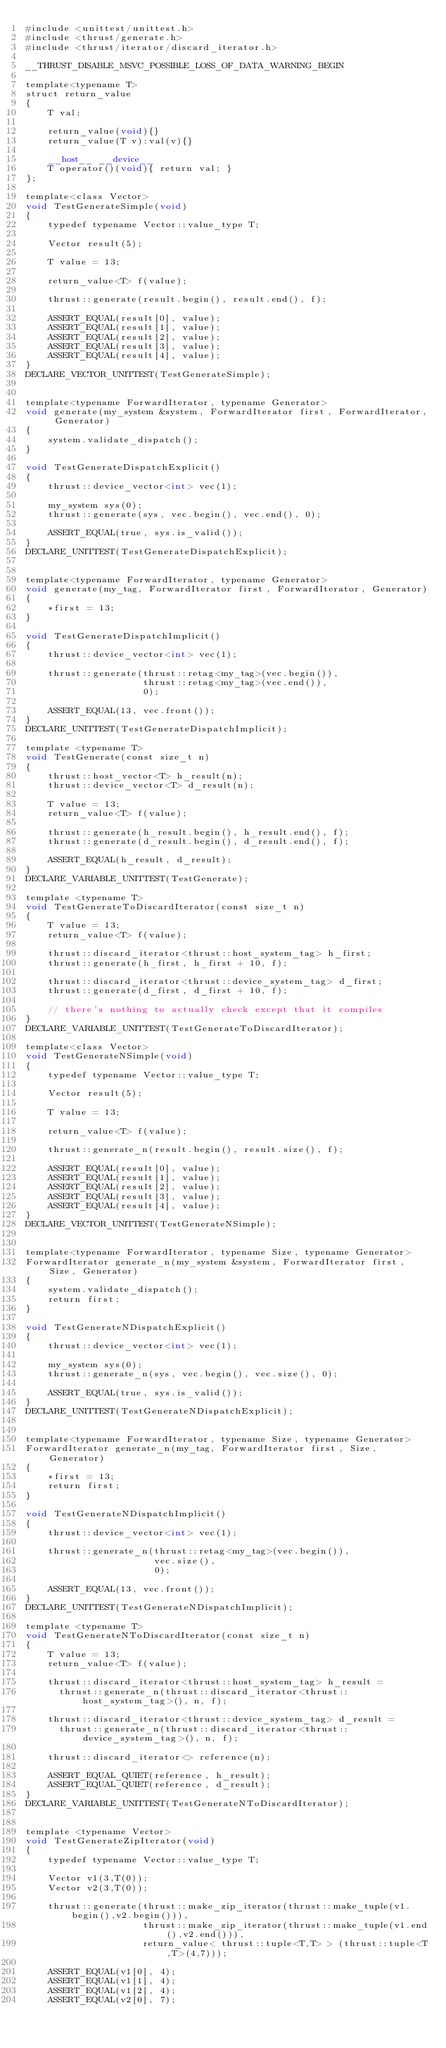Convert code to text. <code><loc_0><loc_0><loc_500><loc_500><_Cuda_>#include <unittest/unittest.h>
#include <thrust/generate.h>
#include <thrust/iterator/discard_iterator.h>

__THRUST_DISABLE_MSVC_POSSIBLE_LOSS_OF_DATA_WARNING_BEGIN

template<typename T>
struct return_value
{
    T val;

    return_value(void){}
    return_value(T v):val(v){}

    __host__ __device__
    T operator()(void){ return val; }
};

template<class Vector>
void TestGenerateSimple(void)
{
    typedef typename Vector::value_type T;

    Vector result(5);

    T value = 13;

    return_value<T> f(value);

    thrust::generate(result.begin(), result.end(), f);

    ASSERT_EQUAL(result[0], value);
    ASSERT_EQUAL(result[1], value);
    ASSERT_EQUAL(result[2], value);
    ASSERT_EQUAL(result[3], value);
    ASSERT_EQUAL(result[4], value);
}
DECLARE_VECTOR_UNITTEST(TestGenerateSimple);


template<typename ForwardIterator, typename Generator>
void generate(my_system &system, ForwardIterator first, ForwardIterator, Generator)
{
    system.validate_dispatch();
}

void TestGenerateDispatchExplicit()
{
    thrust::device_vector<int> vec(1);

    my_system sys(0);
    thrust::generate(sys, vec.begin(), vec.end(), 0);

    ASSERT_EQUAL(true, sys.is_valid());
}
DECLARE_UNITTEST(TestGenerateDispatchExplicit);


template<typename ForwardIterator, typename Generator>
void generate(my_tag, ForwardIterator first, ForwardIterator, Generator)
{
    *first = 13;
}

void TestGenerateDispatchImplicit()
{
    thrust::device_vector<int> vec(1);

    thrust::generate(thrust::retag<my_tag>(vec.begin()),
                     thrust::retag<my_tag>(vec.end()),
                     0);

    ASSERT_EQUAL(13, vec.front());
}
DECLARE_UNITTEST(TestGenerateDispatchImplicit);

template <typename T>
void TestGenerate(const size_t n)
{
    thrust::host_vector<T> h_result(n);
    thrust::device_vector<T> d_result(n);

    T value = 13;
    return_value<T> f(value);

    thrust::generate(h_result.begin(), h_result.end(), f);
    thrust::generate(d_result.begin(), d_result.end(), f);

    ASSERT_EQUAL(h_result, d_result);
}
DECLARE_VARIABLE_UNITTEST(TestGenerate);

template <typename T>
void TestGenerateToDiscardIterator(const size_t n)
{
    T value = 13;
    return_value<T> f(value);

    thrust::discard_iterator<thrust::host_system_tag> h_first;
    thrust::generate(h_first, h_first + 10, f);

    thrust::discard_iterator<thrust::device_system_tag> d_first;
    thrust::generate(d_first, d_first + 10, f);

    // there's nothing to actually check except that it compiles
}
DECLARE_VARIABLE_UNITTEST(TestGenerateToDiscardIterator);

template<class Vector>
void TestGenerateNSimple(void)
{
    typedef typename Vector::value_type T;

    Vector result(5);

    T value = 13;

    return_value<T> f(value);

    thrust::generate_n(result.begin(), result.size(), f);

    ASSERT_EQUAL(result[0], value);
    ASSERT_EQUAL(result[1], value);
    ASSERT_EQUAL(result[2], value);
    ASSERT_EQUAL(result[3], value);
    ASSERT_EQUAL(result[4], value);
}
DECLARE_VECTOR_UNITTEST(TestGenerateNSimple);


template<typename ForwardIterator, typename Size, typename Generator>
ForwardIterator generate_n(my_system &system, ForwardIterator first, Size, Generator)
{
    system.validate_dispatch();
    return first;
}

void TestGenerateNDispatchExplicit()
{
    thrust::device_vector<int> vec(1);

    my_system sys(0);
    thrust::generate_n(sys, vec.begin(), vec.size(), 0);

    ASSERT_EQUAL(true, sys.is_valid());
}
DECLARE_UNITTEST(TestGenerateNDispatchExplicit);


template<typename ForwardIterator, typename Size, typename Generator>
ForwardIterator generate_n(my_tag, ForwardIterator first, Size, Generator)
{
    *first = 13;
    return first;
}

void TestGenerateNDispatchImplicit()
{
    thrust::device_vector<int> vec(1);

    thrust::generate_n(thrust::retag<my_tag>(vec.begin()),
                       vec.size(),
                       0);

    ASSERT_EQUAL(13, vec.front());
}
DECLARE_UNITTEST(TestGenerateNDispatchImplicit);

template <typename T>
void TestGenerateNToDiscardIterator(const size_t n)
{
    T value = 13;
    return_value<T> f(value);

    thrust::discard_iterator<thrust::host_system_tag> h_result = 
      thrust::generate_n(thrust::discard_iterator<thrust::host_system_tag>(), n, f);

    thrust::discard_iterator<thrust::device_system_tag> d_result = 
      thrust::generate_n(thrust::discard_iterator<thrust::device_system_tag>(), n, f);

    thrust::discard_iterator<> reference(n);

    ASSERT_EQUAL_QUIET(reference, h_result);
    ASSERT_EQUAL_QUIET(reference, d_result);
}
DECLARE_VARIABLE_UNITTEST(TestGenerateNToDiscardIterator);


template <typename Vector>
void TestGenerateZipIterator(void)
{
    typedef typename Vector::value_type T;

    Vector v1(3,T(0));
    Vector v2(3,T(0));

    thrust::generate(thrust::make_zip_iterator(thrust::make_tuple(v1.begin(),v2.begin())),
                     thrust::make_zip_iterator(thrust::make_tuple(v1.end(),v2.end())),
                     return_value< thrust::tuple<T,T> > (thrust::tuple<T,T>(4,7)));

    ASSERT_EQUAL(v1[0], 4);
    ASSERT_EQUAL(v1[1], 4);
    ASSERT_EQUAL(v1[2], 4);
    ASSERT_EQUAL(v2[0], 7);</code> 